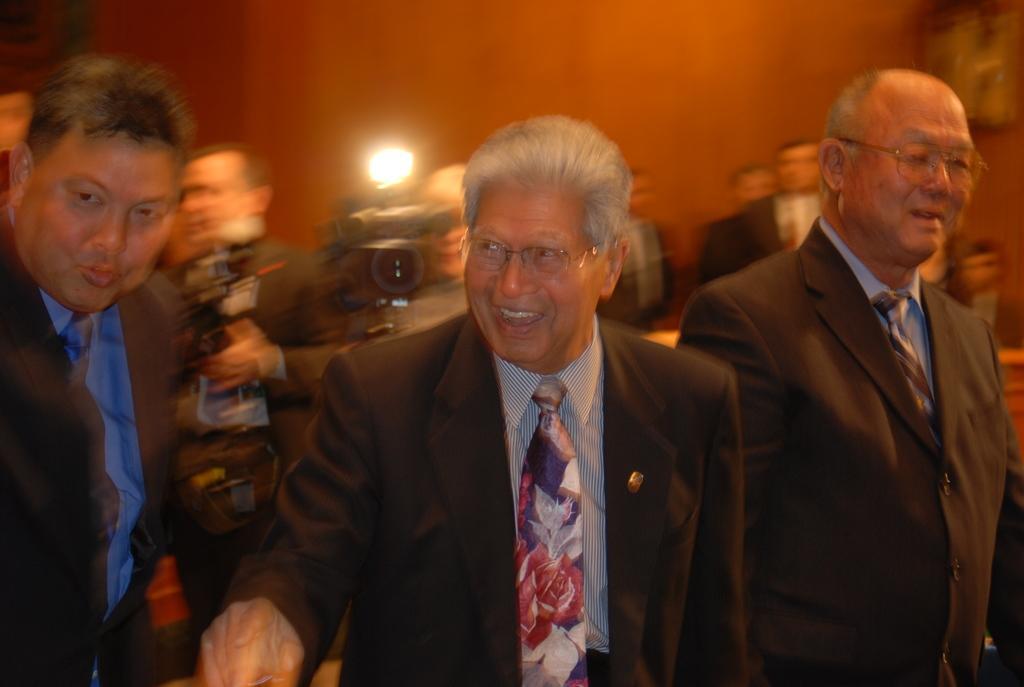How would you summarize this image in a sentence or two? In this picture we can see 3 people standing and smiling at someone. In the background we can see camera flashes. 